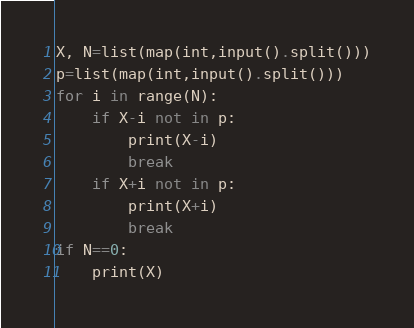<code> <loc_0><loc_0><loc_500><loc_500><_Python_>X, N=list(map(int,input().split()))
p=list(map(int,input().split()))
for i in range(N):
    if X-i not in p:
        print(X-i)
        break
    if X+i not in p:
        print(X+i)
        break
if N==0:
    print(X)</code> 